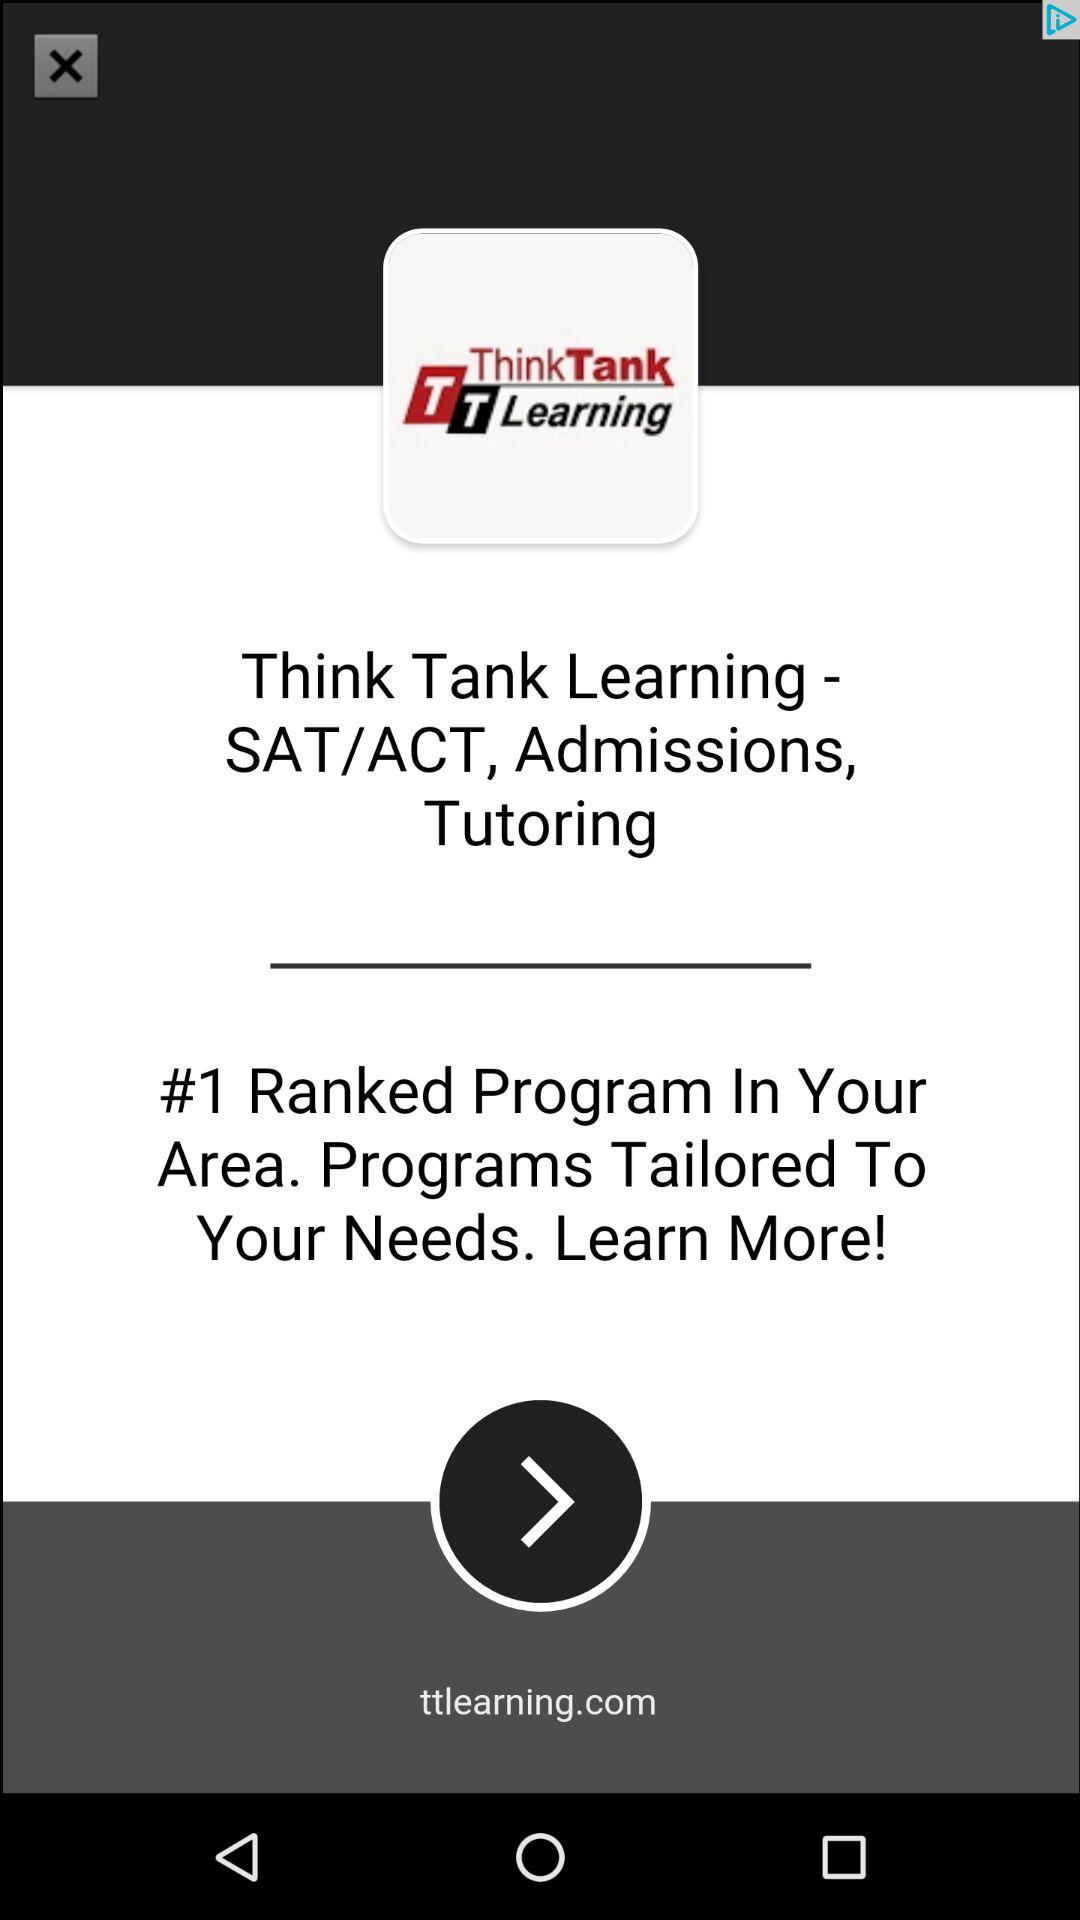What is the application name? The application name is "Think Tank Learning". 